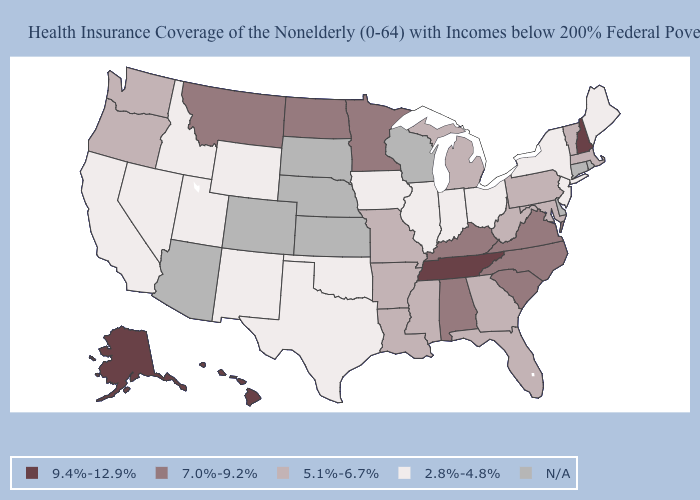What is the value of Arizona?
Short answer required. N/A. What is the value of Connecticut?
Write a very short answer. N/A. Does the first symbol in the legend represent the smallest category?
Concise answer only. No. What is the value of Maine?
Quick response, please. 2.8%-4.8%. Among the states that border Arkansas , which have the lowest value?
Short answer required. Oklahoma, Texas. What is the lowest value in the USA?
Answer briefly. 2.8%-4.8%. What is the highest value in the MidWest ?
Concise answer only. 7.0%-9.2%. Name the states that have a value in the range N/A?
Write a very short answer. Arizona, Colorado, Connecticut, Delaware, Kansas, Nebraska, Rhode Island, South Dakota, Wisconsin. Which states have the lowest value in the South?
Quick response, please. Oklahoma, Texas. Does North Dakota have the highest value in the USA?
Write a very short answer. No. Does the map have missing data?
Give a very brief answer. Yes. What is the value of Delaware?
Be succinct. N/A. Does the map have missing data?
Keep it brief. Yes. What is the lowest value in the USA?
Short answer required. 2.8%-4.8%. 